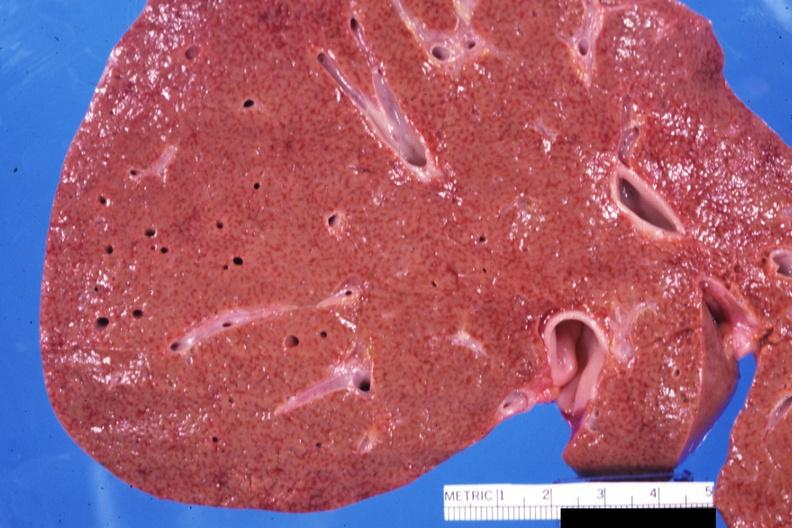what is present?
Answer the question using a single word or phrase. Hepatobiliary 